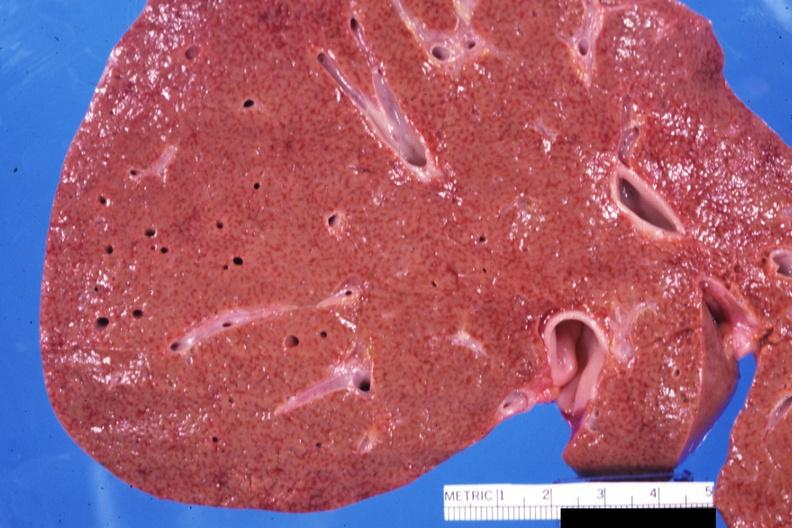what is present?
Answer the question using a single word or phrase. Hepatobiliary 